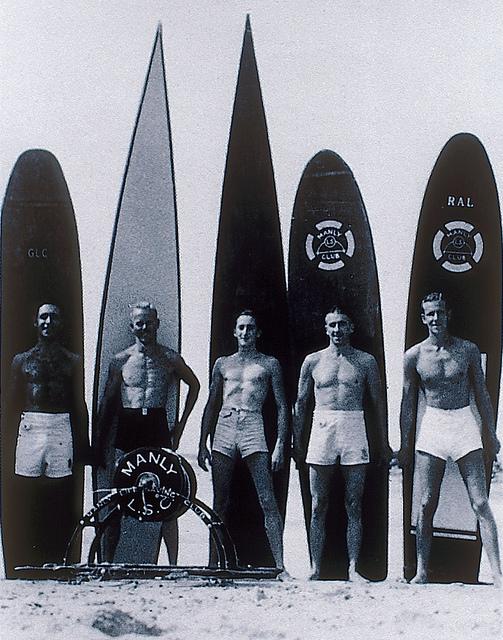Are these surfboards old and ugly?
Short answer required. No. Is the image in black and white?
Keep it brief. Yes. How many men are in this picture?
Write a very short answer. 5. 